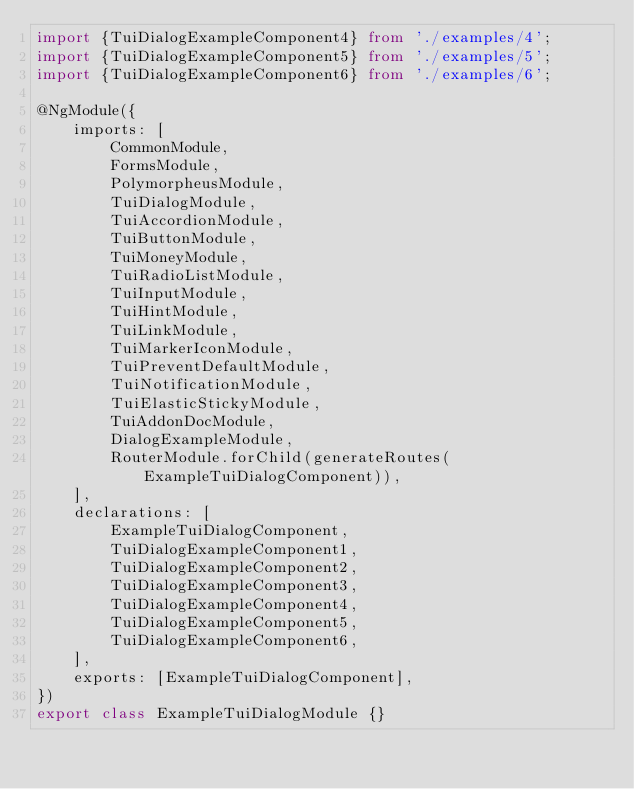<code> <loc_0><loc_0><loc_500><loc_500><_TypeScript_>import {TuiDialogExampleComponent4} from './examples/4';
import {TuiDialogExampleComponent5} from './examples/5';
import {TuiDialogExampleComponent6} from './examples/6';

@NgModule({
    imports: [
        CommonModule,
        FormsModule,
        PolymorpheusModule,
        TuiDialogModule,
        TuiAccordionModule,
        TuiButtonModule,
        TuiMoneyModule,
        TuiRadioListModule,
        TuiInputModule,
        TuiHintModule,
        TuiLinkModule,
        TuiMarkerIconModule,
        TuiPreventDefaultModule,
        TuiNotificationModule,
        TuiElasticStickyModule,
        TuiAddonDocModule,
        DialogExampleModule,
        RouterModule.forChild(generateRoutes(ExampleTuiDialogComponent)),
    ],
    declarations: [
        ExampleTuiDialogComponent,
        TuiDialogExampleComponent1,
        TuiDialogExampleComponent2,
        TuiDialogExampleComponent3,
        TuiDialogExampleComponent4,
        TuiDialogExampleComponent5,
        TuiDialogExampleComponent6,
    ],
    exports: [ExampleTuiDialogComponent],
})
export class ExampleTuiDialogModule {}
</code> 